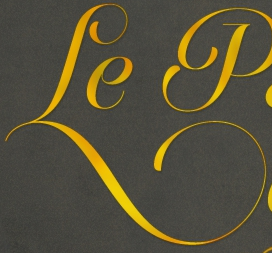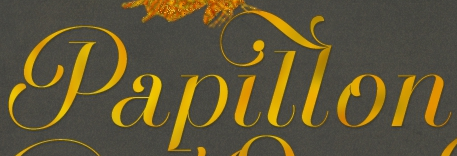Transcribe the words shown in these images in order, separated by a semicolon. Le; Papillon 